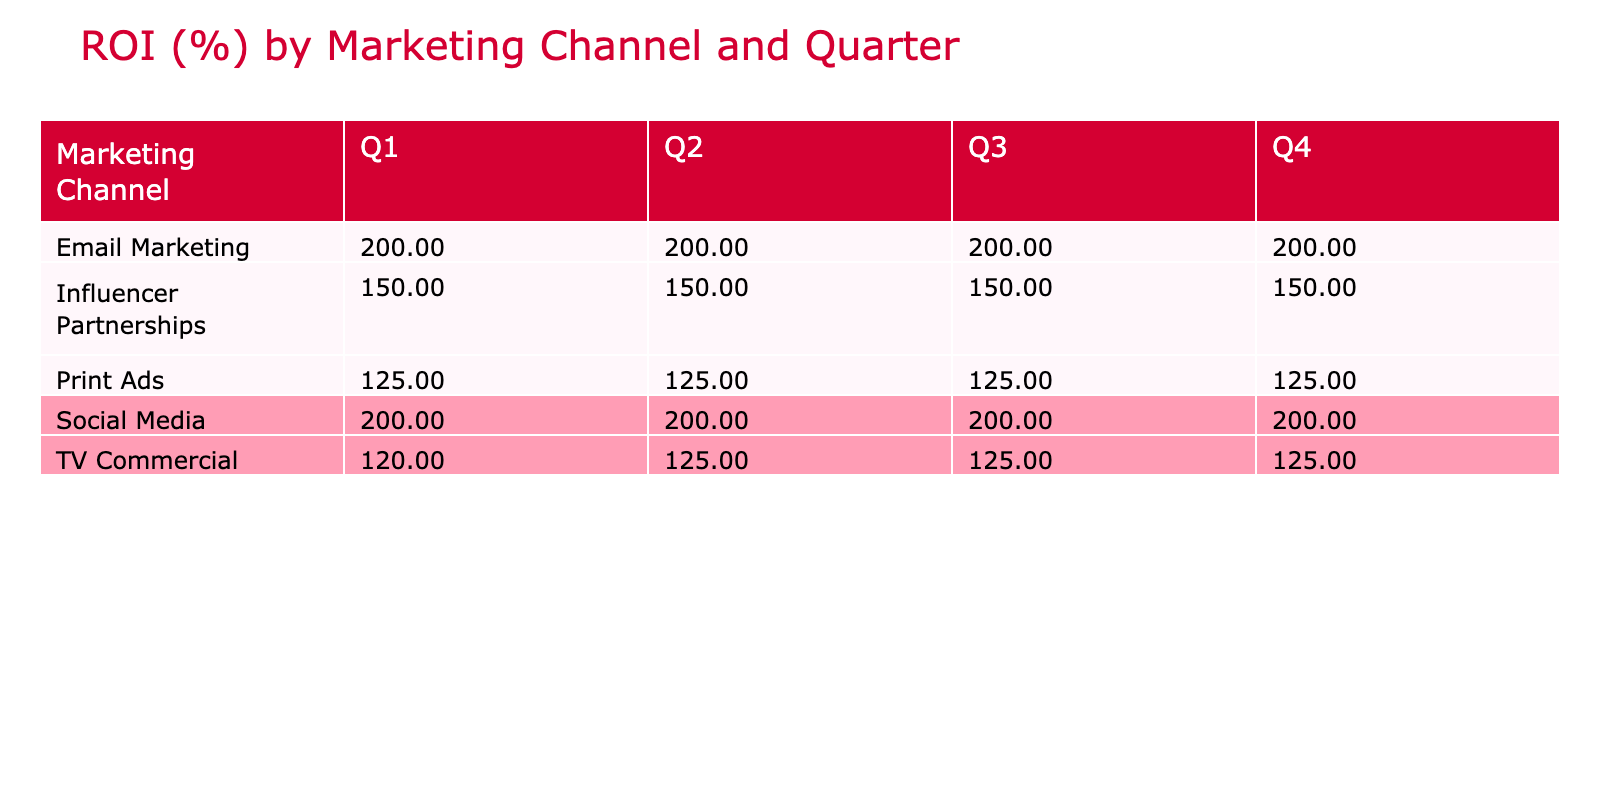What is the ROI for Social Media in Q2? The table shows the ROI for the Social Media channel in Q2 listed under its respective column, which is 200%.
Answer: 200% Which marketing channel had the lowest average ROI across all quarters? To find this, we need to look at all the ROI values for each marketing channel across the quarters. Print Ads have an average ROI of (125 + 125 + 125 + 125) / 4 = 125%. This is lower than any other channel's average ROI.
Answer: Print Ads Is the ROI for TV Commercials the same in Q3 and Q4? The ROI for TV Commercials in Q3 is 125% and in Q4 is also 125%. Since both values are identical, the answer is yes.
Answer: Yes What is the total ROI for Email Marketing across all quarters? We sum the ROIs for Email Marketing from each quarter: (200 + 200 + 200 + 200) = 800%. Then, we divide by the number of quarters (4) to find the average ROI: 800% / 4 = 200%.
Answer: 200% Which marketing channel had the highest ROI in Q1? By checking the Q1 column, Social Media with the campaign Sweet Tooth Temptations had the highest ROI at 200%.
Answer: Social Media Is the average ROI for Influencer Partnerships greater than 150%? First, check the ROI values for Influencer Partnerships: (150 + 150 + 150 + 150) / 4 = 150%. Since the average is equal to 150%, the answer is no.
Answer: No What is the difference in ROI between Email Marketing in Q1 and Q2? The ROI for Email Marketing in Q1 is 200% and in Q2 is also 200%. Therefore, the difference is 200% - 200% = 0%.
Answer: 0% What was the marketing channel with the highest ROI in Q3? In Q3, Social Media with the campaign Summer Sweetness shows the highest ROI at 200%.
Answer: Social Media 